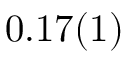<formula> <loc_0><loc_0><loc_500><loc_500>0 . 1 7 ( 1 )</formula> 